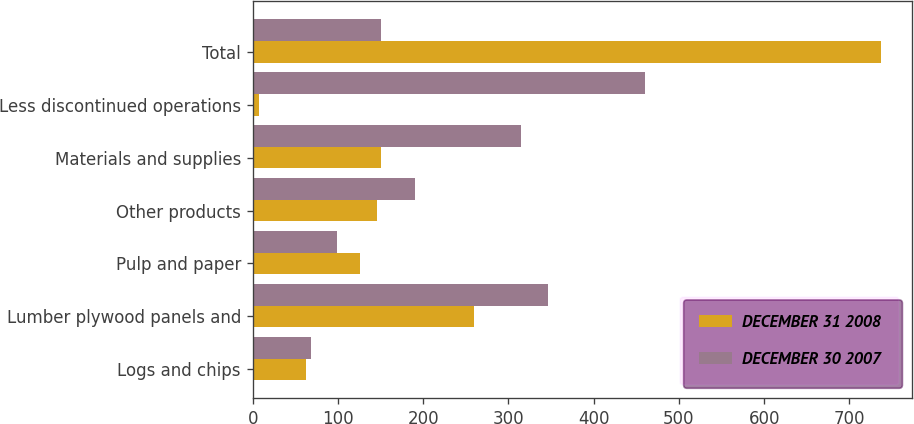<chart> <loc_0><loc_0><loc_500><loc_500><stacked_bar_chart><ecel><fcel>Logs and chips<fcel>Lumber plywood panels and<fcel>Pulp and paper<fcel>Other products<fcel>Materials and supplies<fcel>Less discontinued operations<fcel>Total<nl><fcel>DECEMBER 31 2008<fcel>63<fcel>260<fcel>126<fcel>146<fcel>150<fcel>8<fcel>737<nl><fcel>DECEMBER 30 2007<fcel>69<fcel>346<fcel>99<fcel>191<fcel>315<fcel>460<fcel>150<nl></chart> 